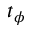Convert formula to latex. <formula><loc_0><loc_0><loc_500><loc_500>t _ { \phi }</formula> 